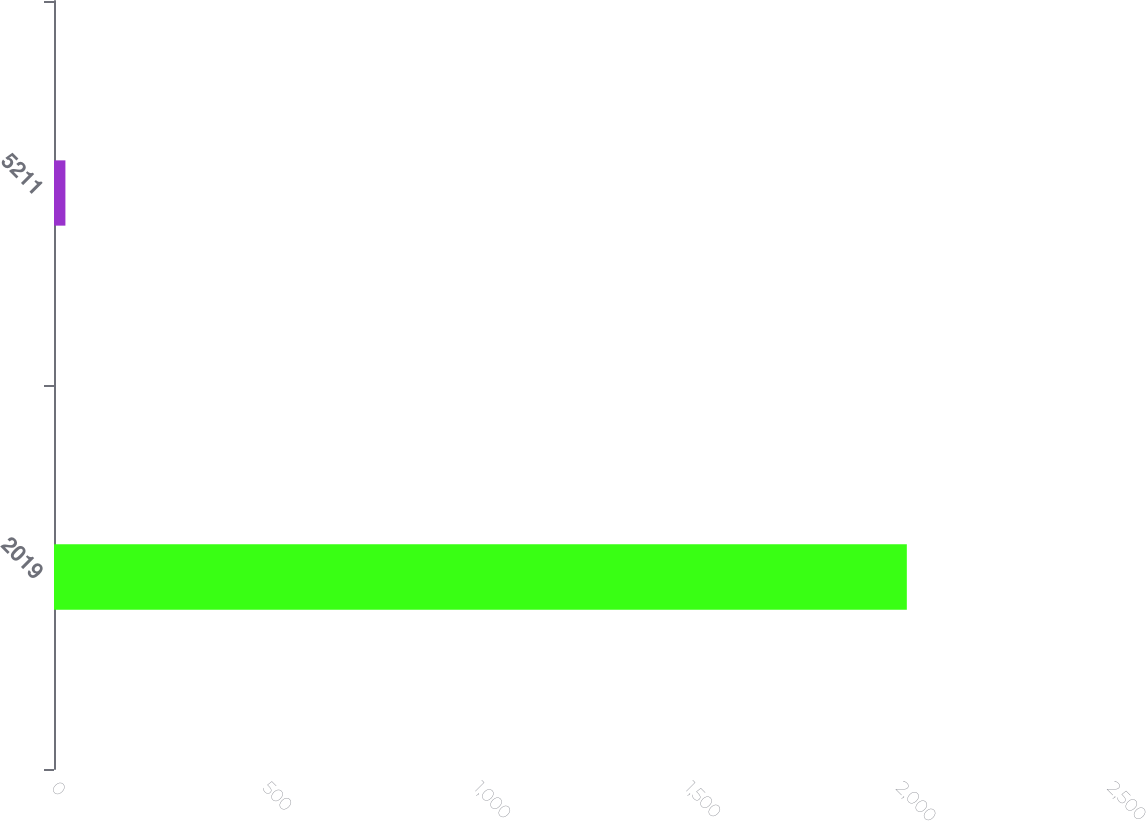Convert chart. <chart><loc_0><loc_0><loc_500><loc_500><bar_chart><fcel>2019<fcel>5211<nl><fcel>2019<fcel>27<nl></chart> 